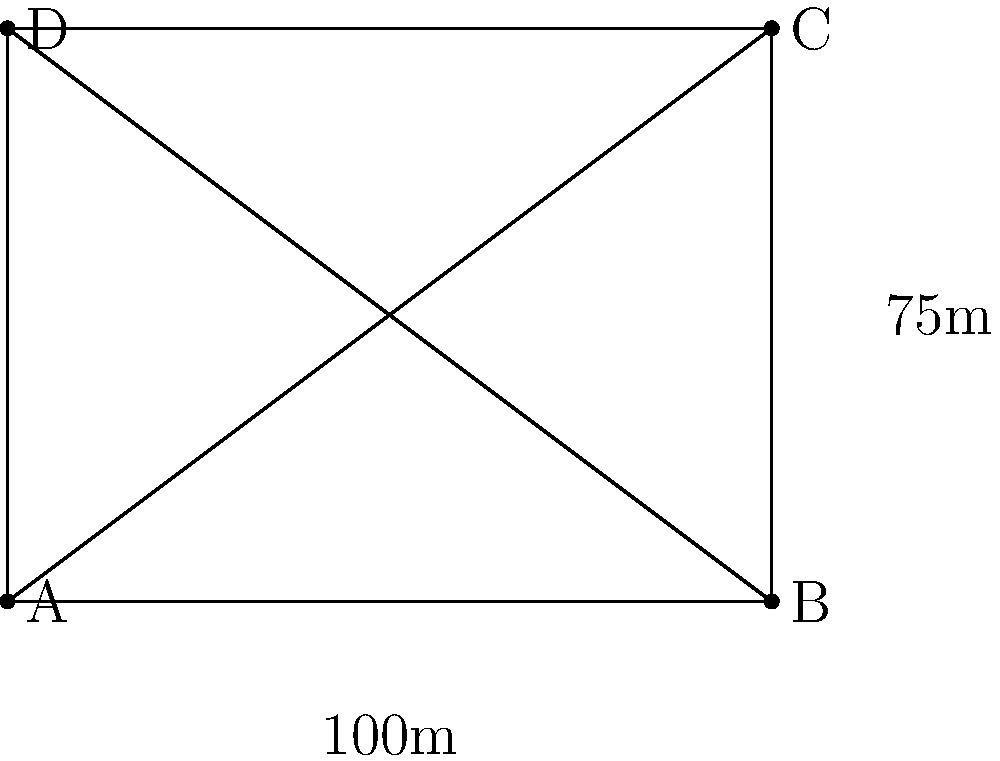In a new real estate development project, you need to connect four buildings (A, B, C, and D) with underground piping. The buildings form a rectangle, where the distance between A and B is 100 meters, and the distance between B and C is 75 meters. What is the minimum total length of piping required to connect all four buildings if the piping must follow the diagonals of the rectangle? To solve this problem, we need to follow these steps:

1) First, we need to calculate the length of the diagonals. The rectangle forms a right triangle, so we can use the Pythagorean theorem.

2) Let's call the diagonal length $x$. Using the Pythagorean theorem:

   $$x^2 = 100^2 + 75^2$$

3) Simplify:
   $$x^2 = 10000 + 5625 = 15625$$

4) Take the square root of both sides:
   $$x = \sqrt{15625} = 125$$

5) So each diagonal is 125 meters long.

6) We need both diagonals to connect all four buildings, so the total length is:

   $$\text{Total length} = 2 * 125 = 250$$

Therefore, the minimum total length of piping required is 250 meters.
Answer: 250 meters 